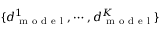<formula> <loc_0><loc_0><loc_500><loc_500>\{ d _ { m o d e l } ^ { 1 } , \cdots , d _ { m o d e l } ^ { K } \}</formula> 